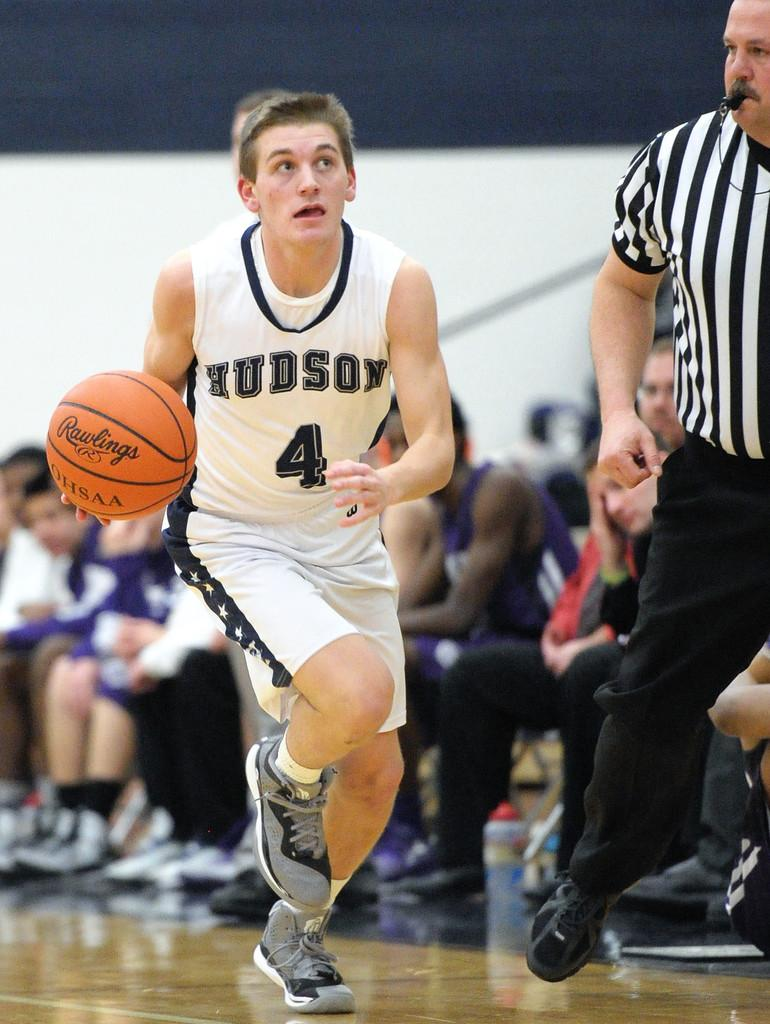<image>
Present a compact description of the photo's key features. kid playing basetball from hudson school number 4 